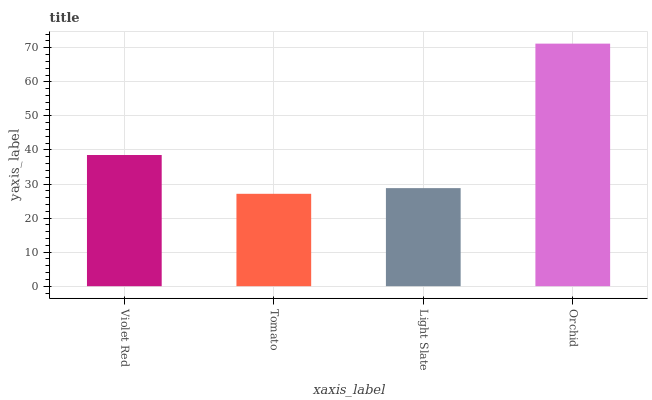Is Tomato the minimum?
Answer yes or no. Yes. Is Orchid the maximum?
Answer yes or no. Yes. Is Light Slate the minimum?
Answer yes or no. No. Is Light Slate the maximum?
Answer yes or no. No. Is Light Slate greater than Tomato?
Answer yes or no. Yes. Is Tomato less than Light Slate?
Answer yes or no. Yes. Is Tomato greater than Light Slate?
Answer yes or no. No. Is Light Slate less than Tomato?
Answer yes or no. No. Is Violet Red the high median?
Answer yes or no. Yes. Is Light Slate the low median?
Answer yes or no. Yes. Is Orchid the high median?
Answer yes or no. No. Is Violet Red the low median?
Answer yes or no. No. 